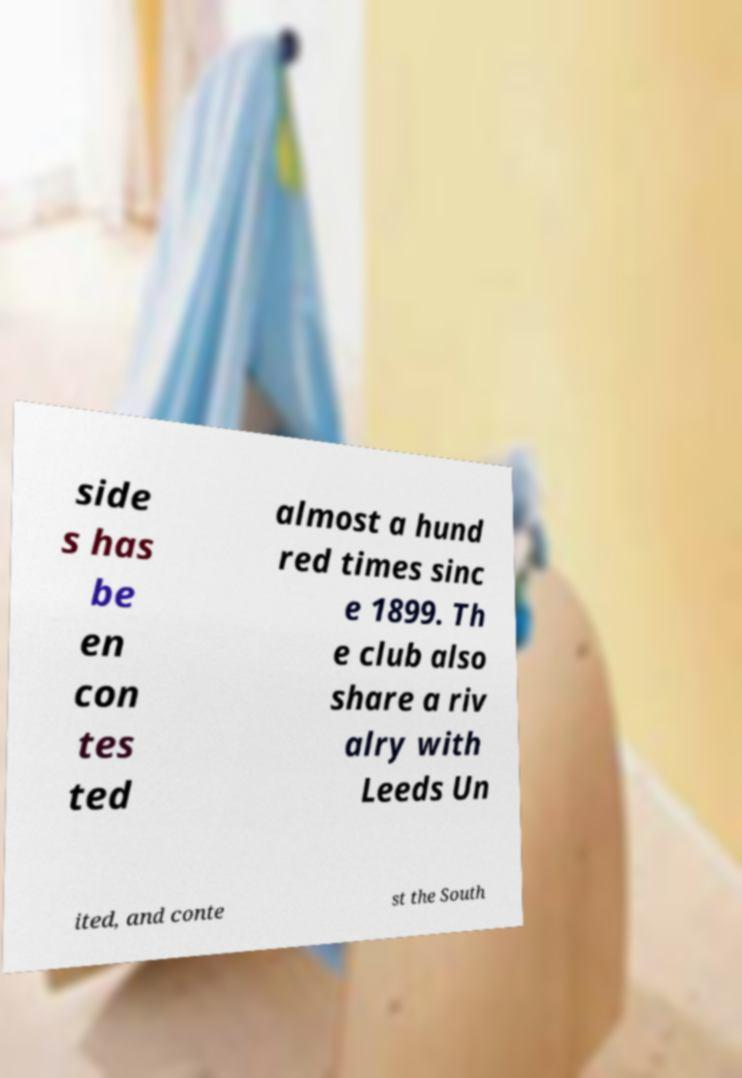Can you accurately transcribe the text from the provided image for me? side s has be en con tes ted almost a hund red times sinc e 1899. Th e club also share a riv alry with Leeds Un ited, and conte st the South 